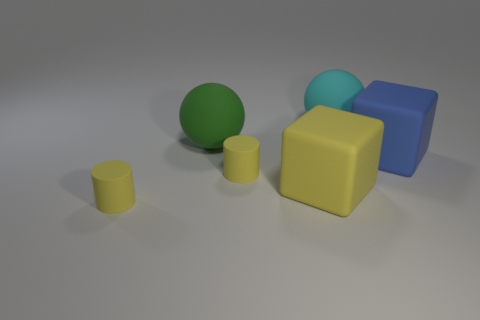Add 4 green rubber cylinders. How many objects exist? 10 Subtract all cylinders. How many objects are left? 4 Subtract all matte blocks. Subtract all big blue blocks. How many objects are left? 3 Add 4 big green rubber balls. How many big green rubber balls are left? 5 Add 1 big blue blocks. How many big blue blocks exist? 2 Subtract 0 purple cubes. How many objects are left? 6 